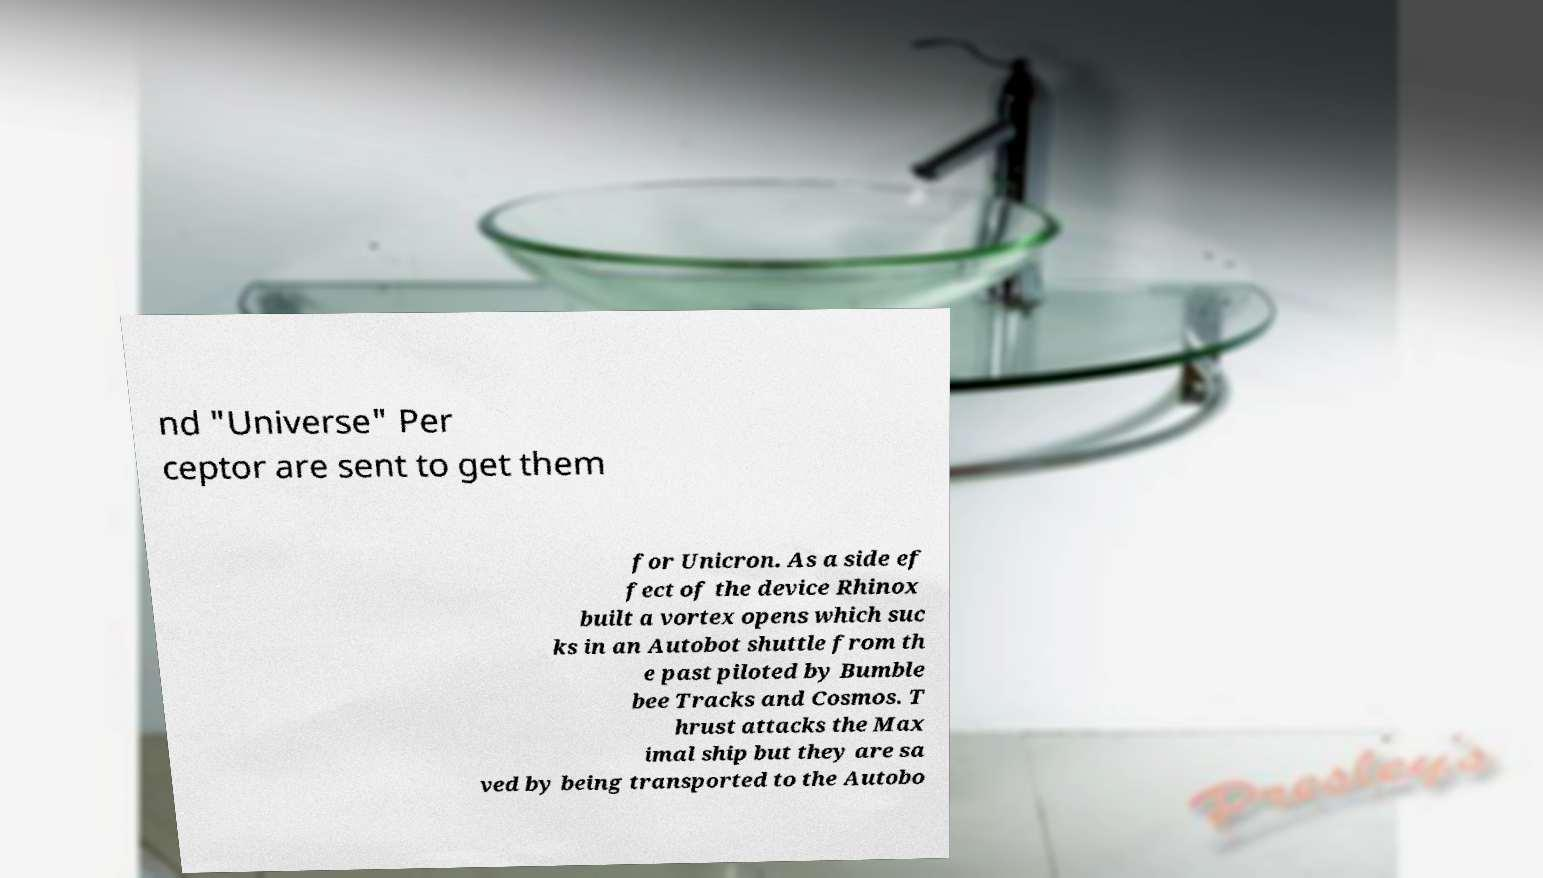Please identify and transcribe the text found in this image. nd "Universe" Per ceptor are sent to get them for Unicron. As a side ef fect of the device Rhinox built a vortex opens which suc ks in an Autobot shuttle from th e past piloted by Bumble bee Tracks and Cosmos. T hrust attacks the Max imal ship but they are sa ved by being transported to the Autobo 